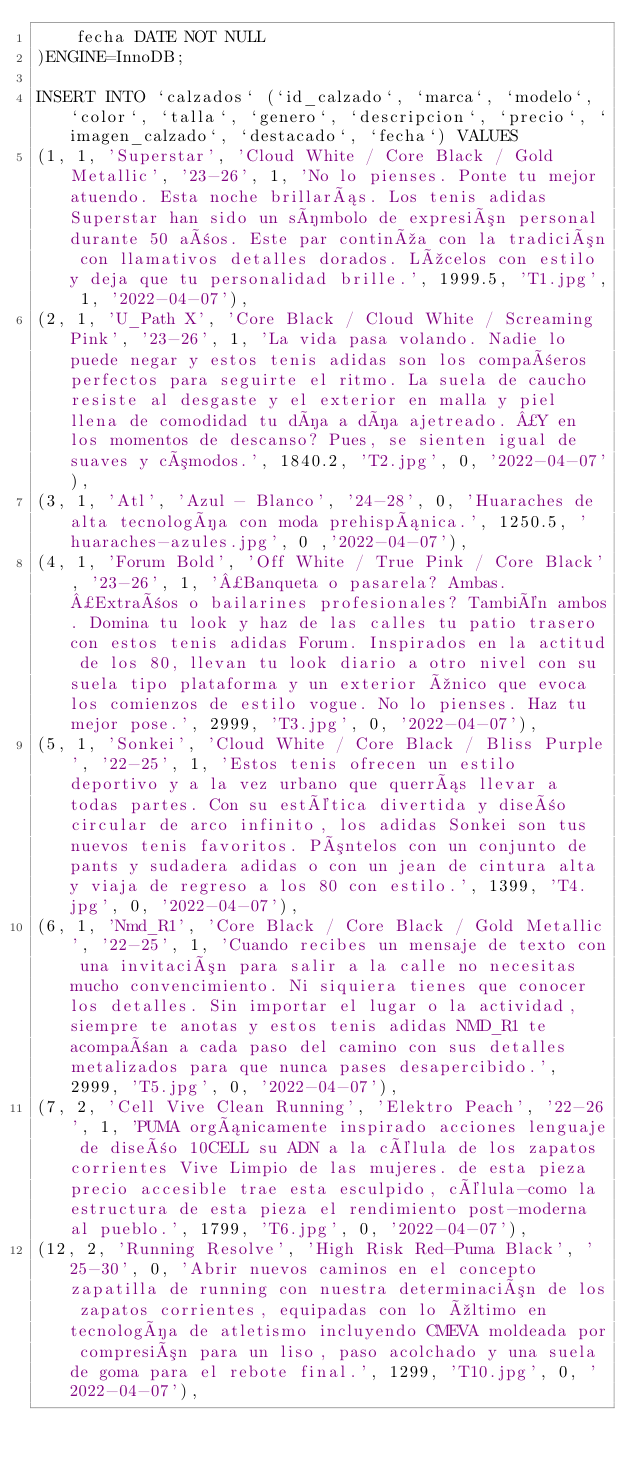Convert code to text. <code><loc_0><loc_0><loc_500><loc_500><_SQL_>    fecha DATE NOT NULL
)ENGINE=InnoDB;

INSERT INTO `calzados` (`id_calzado`, `marca`, `modelo`, `color`, `talla`, `genero`, `descripcion`, `precio`, `imagen_calzado`, `destacado`, `fecha`) VALUES
(1, 1, 'Superstar', 'Cloud White / Core Black / Gold Metallic', '23-26', 1, 'No lo pienses. Ponte tu mejor atuendo. Esta noche brillarás. Los tenis adidas Superstar han sido un símbolo de expresión personal durante 50 años. Este par continúa con la tradición con llamativos detalles dorados. Lúcelos con estilo y deja que tu personalidad brille.', 1999.5, 'T1.jpg', 1, '2022-04-07'),
(2, 1, 'U_Path X', 'Core Black / Cloud White / Screaming Pink', '23-26', 1, 'La vida pasa volando. Nadie lo puede negar y estos tenis adidas son los compañeros perfectos para seguirte el ritmo. La suela de caucho resiste al desgaste y el exterior en malla y piel llena de comodidad tu día a día ajetreado. ¿Y en los momentos de descanso? Pues, se sienten igual de suaves y cómodos.', 1840.2, 'T2.jpg', 0, '2022-04-07'),
(3, 1, 'Atl', 'Azul - Blanco', '24-28', 0, 'Huaraches de alta tecnología con moda prehispánica.', 1250.5, 'huaraches-azules.jpg', 0 ,'2022-04-07'),
(4, 1, 'Forum Bold', 'Off White / True Pink / Core Black', '23-26', 1, '¿Banqueta o pasarela? Ambas. ¿Extraños o bailarines profesionales? También ambos. Domina tu look y haz de las calles tu patio trasero con estos tenis adidas Forum. Inspirados en la actitud de los 80, llevan tu look diario a otro nivel con su suela tipo plataforma y un exterior único que evoca los comienzos de estilo vogue. No lo pienses. Haz tu mejor pose.', 2999, 'T3.jpg', 0, '2022-04-07'),
(5, 1, 'Sonkei', 'Cloud White / Core Black / Bliss Purple', '22-25', 1, 'Estos tenis ofrecen un estilo deportivo y a la vez urbano que querrás llevar a todas partes. Con su estética divertida y diseño circular de arco infinito, los adidas Sonkei son tus nuevos tenis favoritos. Póntelos con un conjunto de pants y sudadera adidas o con un jean de cintura alta y viaja de regreso a los 80 con estilo.', 1399, 'T4.jpg', 0, '2022-04-07'),
(6, 1, 'Nmd_R1', 'Core Black / Core Black / Gold Metallic', '22-25', 1, 'Cuando recibes un mensaje de texto con una invitación para salir a la calle no necesitas mucho convencimiento. Ni siquiera tienes que conocer los detalles. Sin importar el lugar o la actividad, siempre te anotas y estos tenis adidas NMD_R1 te acompañan a cada paso del camino con sus detalles metalizados para que nunca pases desapercibido.', 2999, 'T5.jpg', 0, '2022-04-07'),
(7, 2, 'Cell Vive Clean Running', 'Elektro Peach', '22-26', 1, 'PUMA orgánicamente inspirado acciones lenguaje de diseño 10CELL su ADN a la célula de los zapatos corrientes Vive Limpio de las mujeres. de esta pieza precio accesible trae esta esculpido, célula-como la estructura de esta pieza el rendimiento post-moderna al pueblo.', 1799, 'T6.jpg', 0, '2022-04-07'),
(12, 2, 'Running Resolve', 'High Risk Red-Puma Black', '25-30', 0, 'Abrir nuevos caminos en el concepto zapatilla de running con nuestra determinación de los zapatos corrientes, equipadas con lo último en tecnología de atletismo incluyendo CMEVA moldeada por compresión para un liso, paso acolchado y una suela de goma para el rebote final.', 1299, 'T10.jpg', 0, '2022-04-07'),</code> 